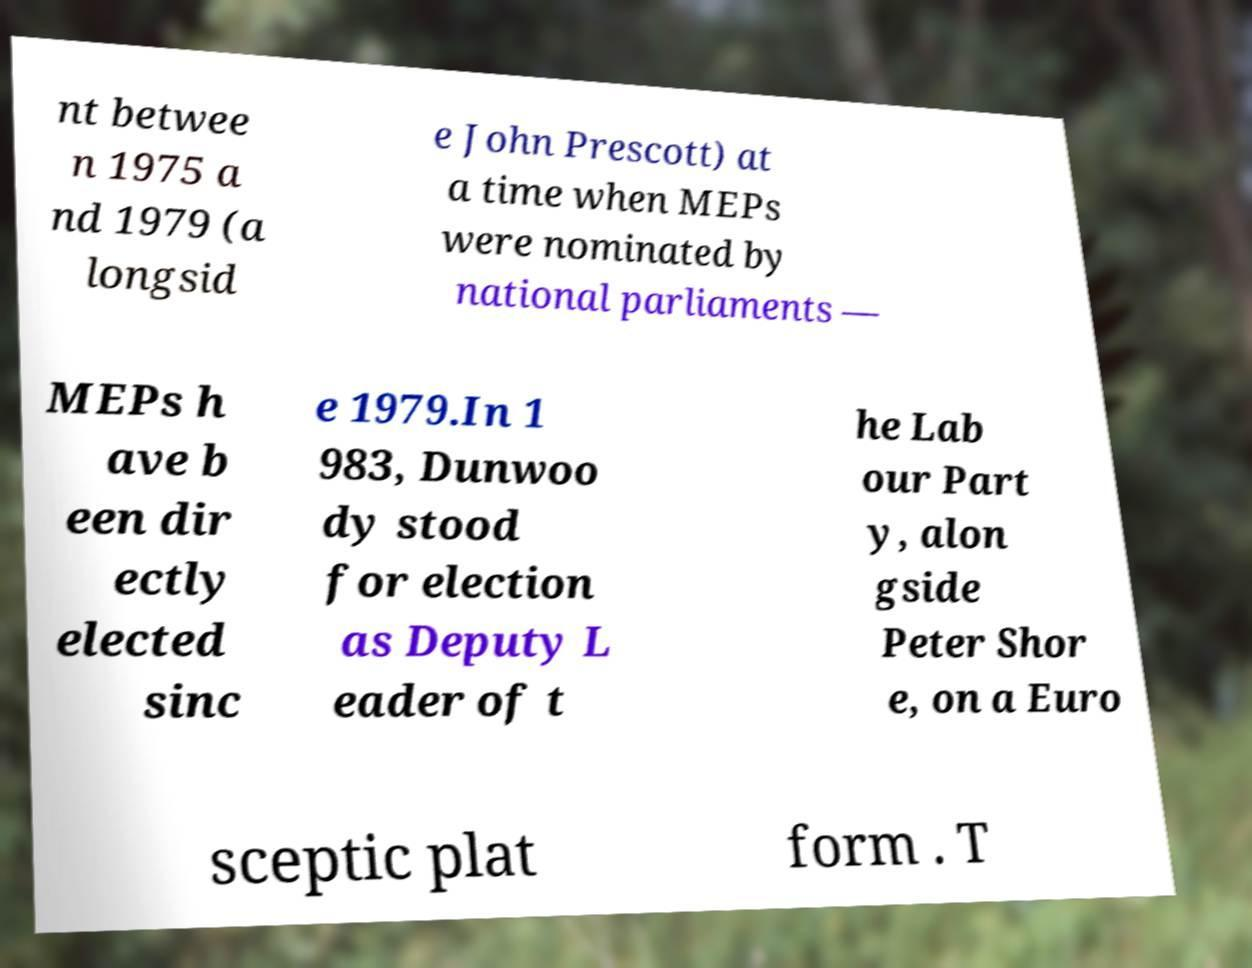Could you assist in decoding the text presented in this image and type it out clearly? nt betwee n 1975 a nd 1979 (a longsid e John Prescott) at a time when MEPs were nominated by national parliaments — MEPs h ave b een dir ectly elected sinc e 1979.In 1 983, Dunwoo dy stood for election as Deputy L eader of t he Lab our Part y, alon gside Peter Shor e, on a Euro sceptic plat form . T 